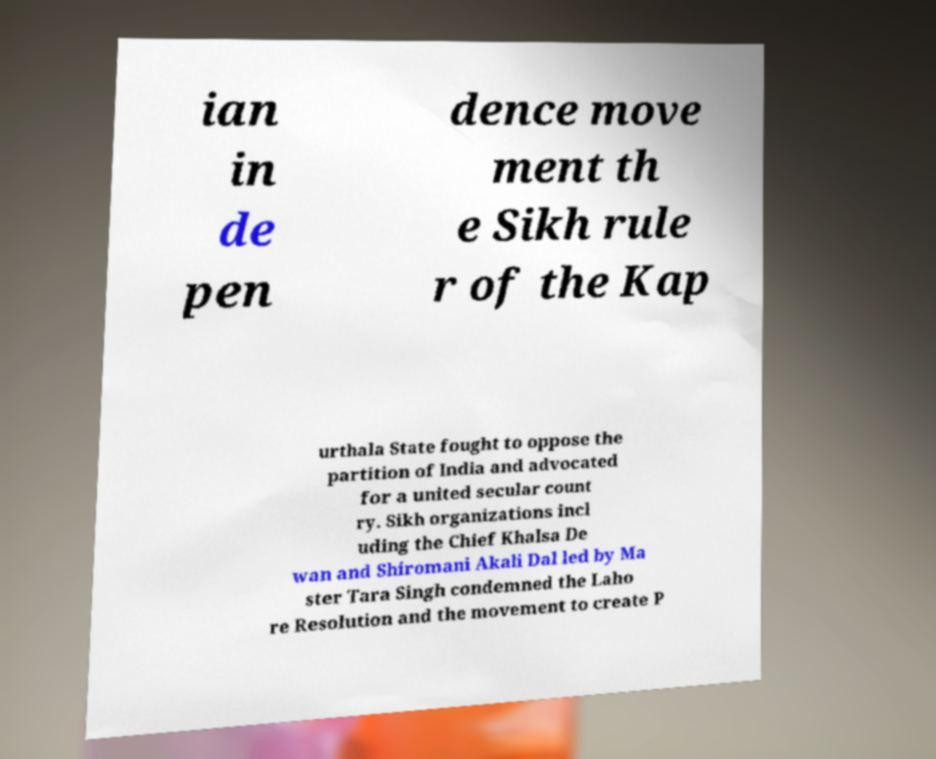There's text embedded in this image that I need extracted. Can you transcribe it verbatim? ian in de pen dence move ment th e Sikh rule r of the Kap urthala State fought to oppose the partition of India and advocated for a united secular count ry. Sikh organizations incl uding the Chief Khalsa De wan and Shiromani Akali Dal led by Ma ster Tara Singh condemned the Laho re Resolution and the movement to create P 